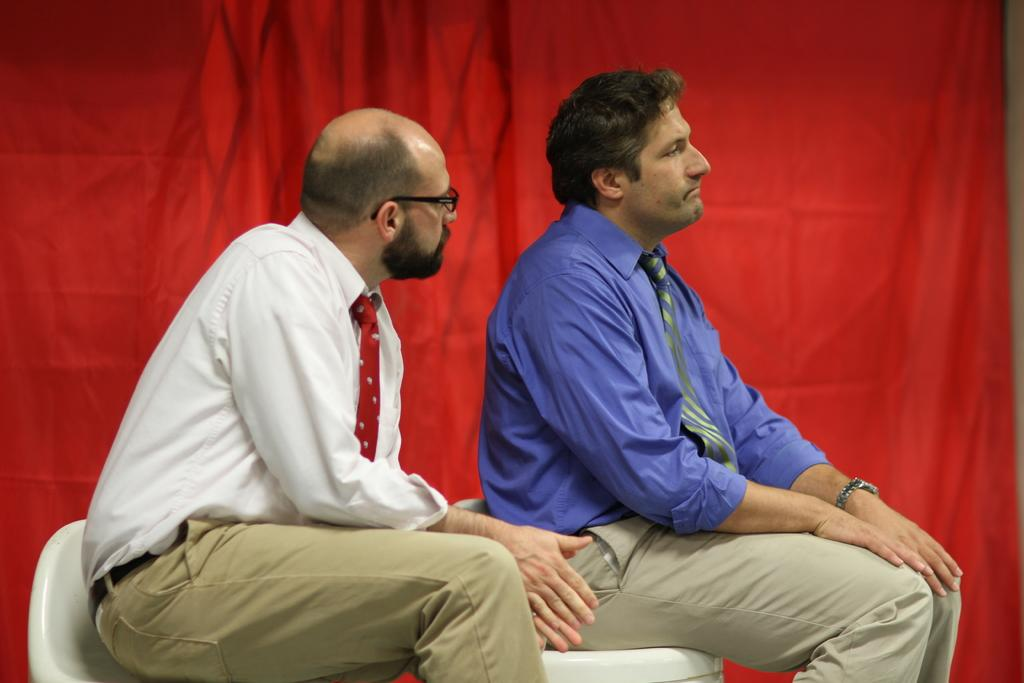How many persons are in the image? There are two persons in the image. What are the persons doing in the image? The persons are sitting on chairs. Can you describe the background of the image? There is a red cloth in the background of the image. What type of bird can be seen sitting on the shoulder of one of the persons in the image? There is no bird visible in the image. What is the relation between the two persons in the image? The provided facts do not give any information about the relationship between the two persons. 